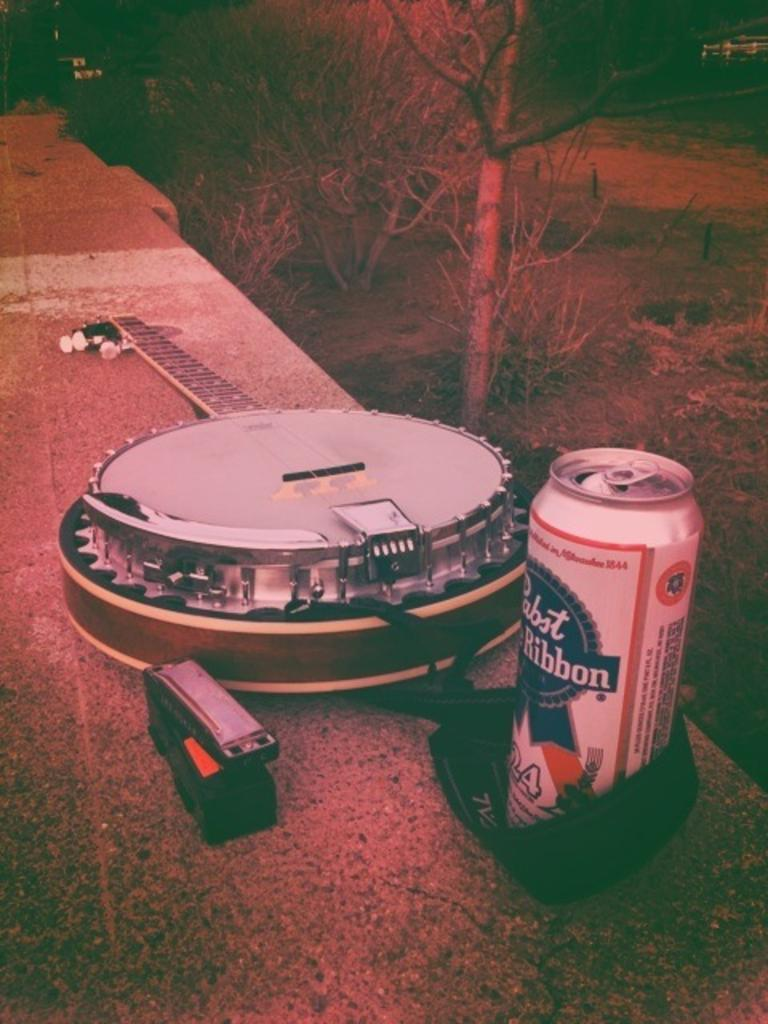<image>
Share a concise interpretation of the image provided. A banjo is sitting on a bench by a harmonica and a can of beer that says Papst Blue Ribbon. 